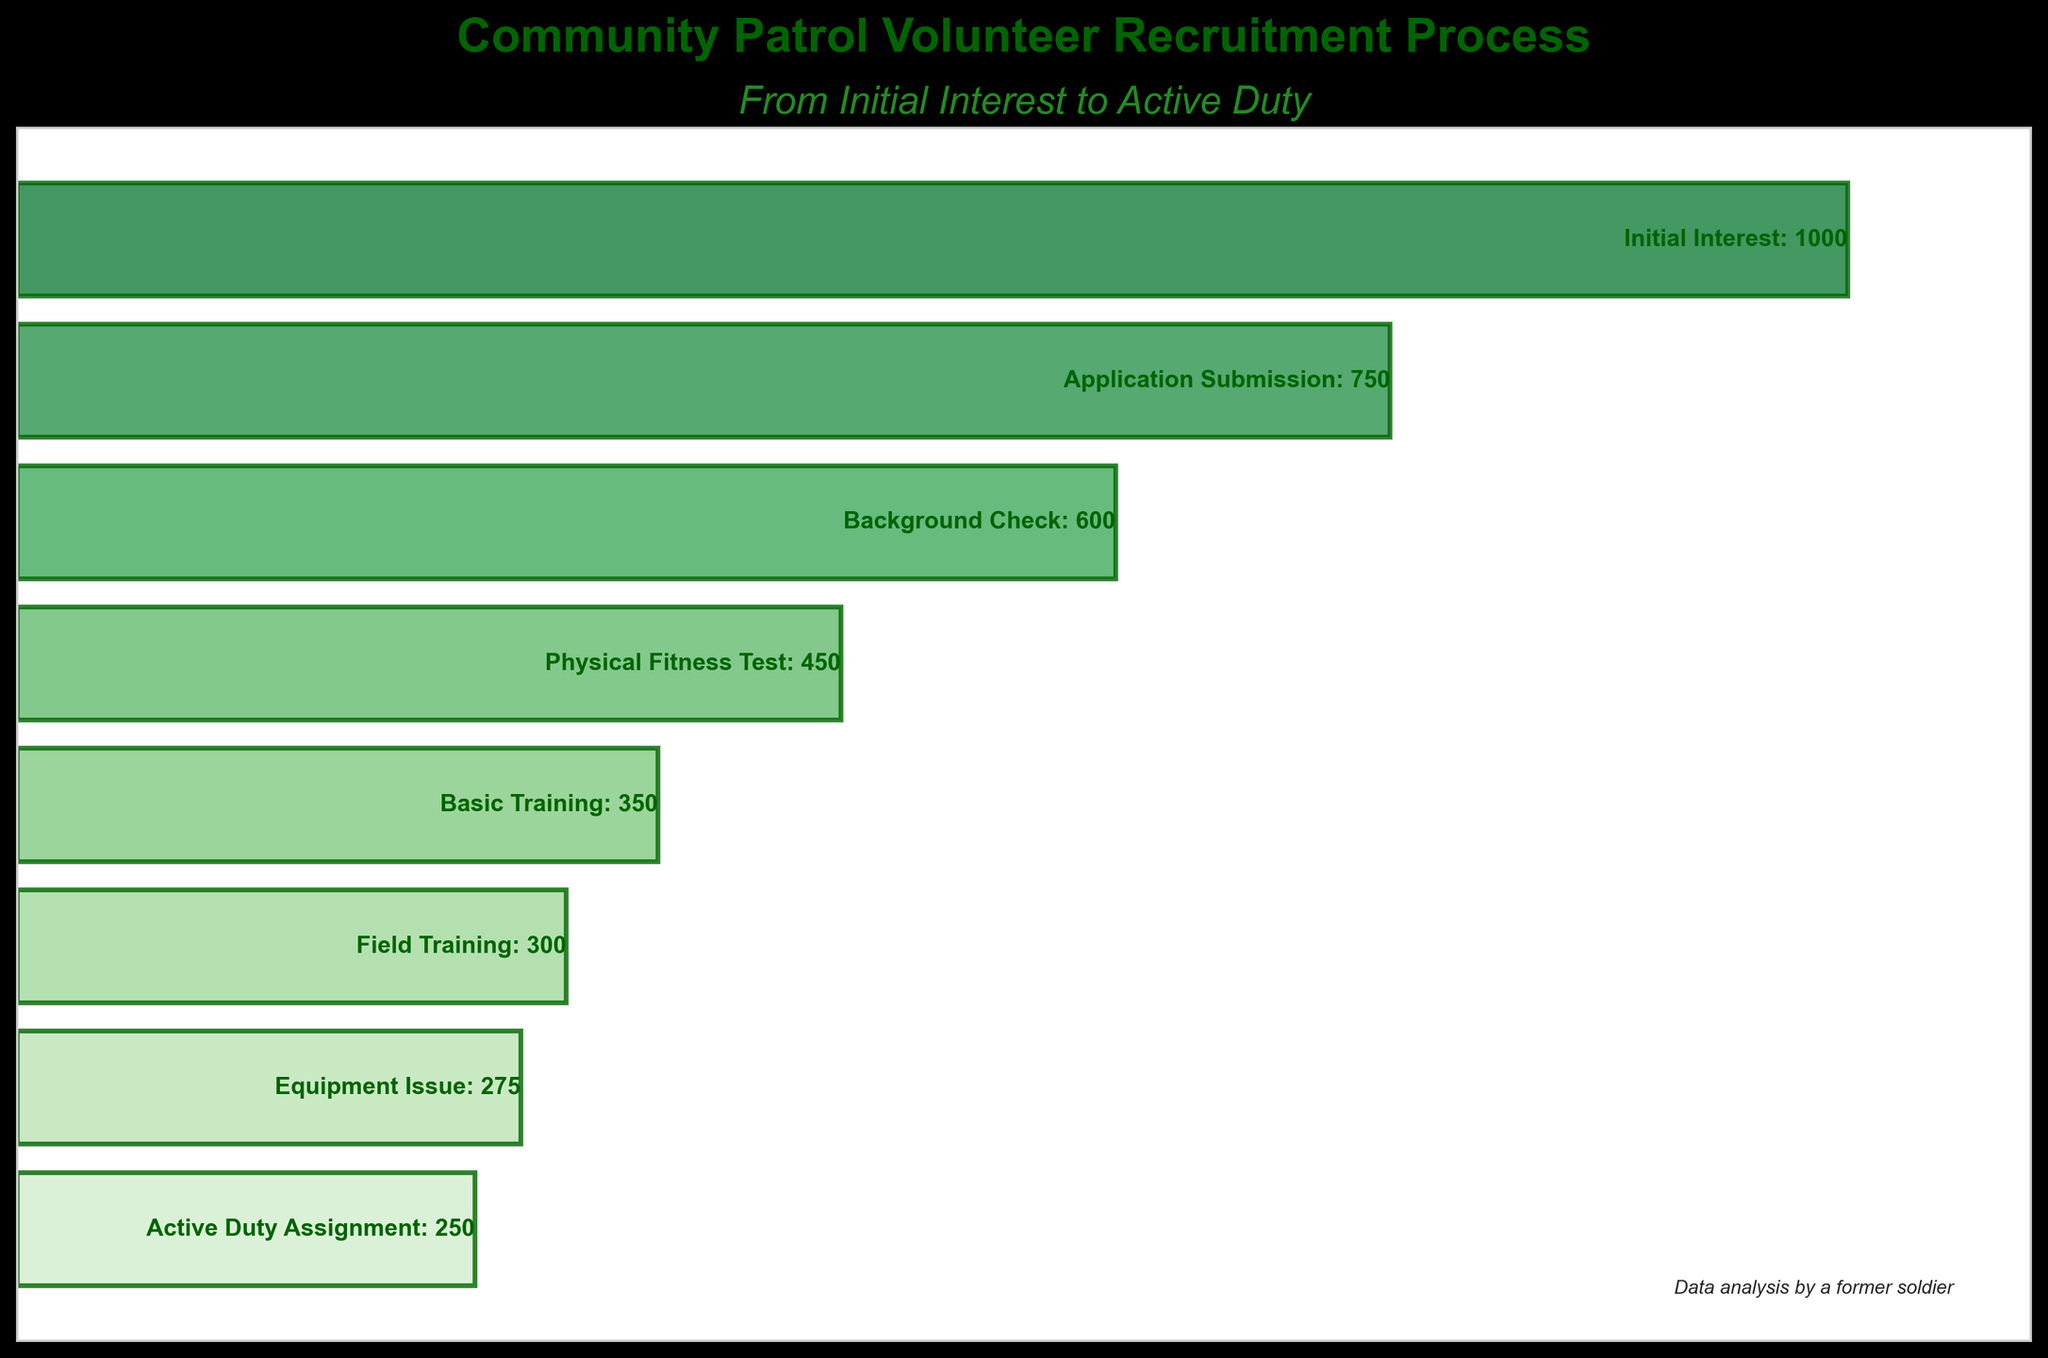How many participants completed the Background Check stage? The label next to the Background Check bar indicates the number of participants as 600.
Answer: 600 Which stage had the largest decrease in participant numbers compared to the previous stage? Calculate the difference in participants between each successive stage and find the largest value: Initial Interest to Application Submission (250), Application Submission to Background Check (150), Background Check to Physical Fitness Test (150), Physical Fitness Test to Basic Training (100), Basic Training to Field Training (50), Field Training to Equipment Issue (25), Equipment Issue to Active Duty Assignment (25). The largest decrease (250) is from Initial Interest to Application Submission.
Answer: Initial Interest to Application Submission What is the title of the chart? The title is at the top of the chart and reads "Community Patrol Volunteer Recruitment Process".
Answer: Community Patrol Volunteer Recruitment Process How many stages are shown in the recruitment process? Count the total number of stages represented by the bars in the funnel chart.
Answer: 8 What is the difference in participant numbers between the stages Basic Training and Field Training? Subtract the number of participants in Field Training (300) from Basic Training (350). The difference is 350 - 300 = 50.
Answer: 50 What is the specific subtitle of the chart? The subtitle is found directly under the main title and reads "From Initial Interest to Active Duty".
Answer: From Initial Interest to Active Duty How many participants progressed from Equipment Issue to Active Duty Assignment? Subtract the number of participants at Active Duty Assignment (250) from those at Equipment Issue (275). The difference is 275 - 250 = 25.
Answer: 25 At which stage do we first see fewer than 500 participants? Scan through the participant numbers in descending order and identify the stage where the number drops below 500 for the first time, which is Physical Fitness Test with 450 participants.
Answer: Physical Fitness Test What color scheme is used for the bars in the chart? The bars use various shades of green, transitioning from lighter shades at the bottom to deeper shades at the top.
Answer: Shades of green 